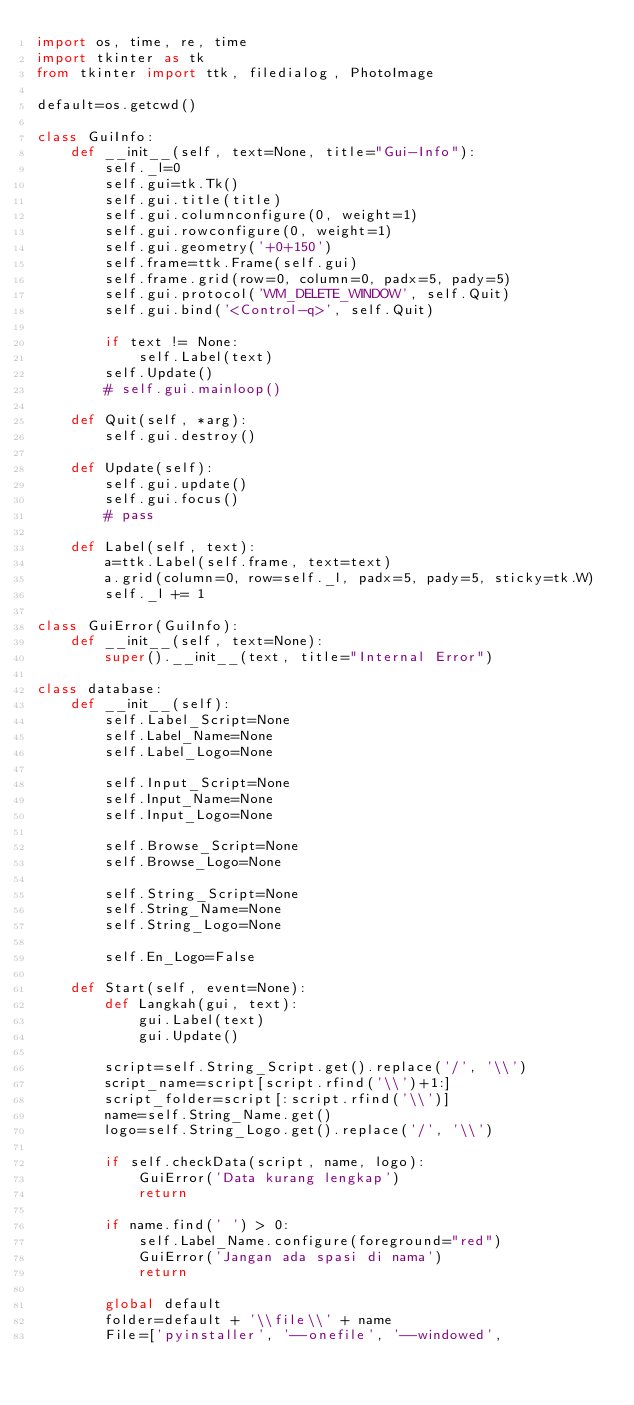<code> <loc_0><loc_0><loc_500><loc_500><_Python_>import os, time, re, time
import tkinter as tk
from tkinter import ttk, filedialog, PhotoImage

default=os.getcwd()

class GuiInfo:
    def __init__(self, text=None, title="Gui-Info"):
        self._l=0
        self.gui=tk.Tk()
        self.gui.title(title)
        self.gui.columnconfigure(0, weight=1)
        self.gui.rowconfigure(0, weight=1)
        self.gui.geometry('+0+150')
        self.frame=ttk.Frame(self.gui)
        self.frame.grid(row=0, column=0, padx=5, pady=5)
        self.gui.protocol('WM_DELETE_WINDOW', self.Quit)
        self.gui.bind('<Control-q>', self.Quit)

        if text != None:
            self.Label(text)
        self.Update()
        # self.gui.mainloop()

    def Quit(self, *arg):
        self.gui.destroy()

    def Update(self):
        self.gui.update()
        self.gui.focus()
        # pass

    def Label(self, text):
        a=ttk.Label(self.frame, text=text)
        a.grid(column=0, row=self._l, padx=5, pady=5, sticky=tk.W)
        self._l += 1

class GuiError(GuiInfo):
    def __init__(self, text=None):
        super().__init__(text, title="Internal Error")

class database:
    def __init__(self):
        self.Label_Script=None
        self.Label_Name=None
        self.Label_Logo=None

        self.Input_Script=None
        self.Input_Name=None
        self.Input_Logo=None

        self.Browse_Script=None
        self.Browse_Logo=None

        self.String_Script=None
        self.String_Name=None
        self.String_Logo=None

        self.En_Logo=False

    def Start(self, event=None):
        def Langkah(gui, text):
            gui.Label(text)
            gui.Update()

        script=self.String_Script.get().replace('/', '\\')
        script_name=script[script.rfind('\\')+1:]
        script_folder=script[:script.rfind('\\')]
        name=self.String_Name.get()
        logo=self.String_Logo.get().replace('/', '\\')
        
        if self.checkData(script, name, logo):
            GuiError('Data kurang lengkap')
            return
        
        if name.find(' ') > 0:
            self.Label_Name.configure(foreground="red")
            GuiError('Jangan ada spasi di nama')
            return

        global default
        folder=default + '\\file\\' + name
        File=['pyinstaller', '--onefile', '--windowed', </code> 